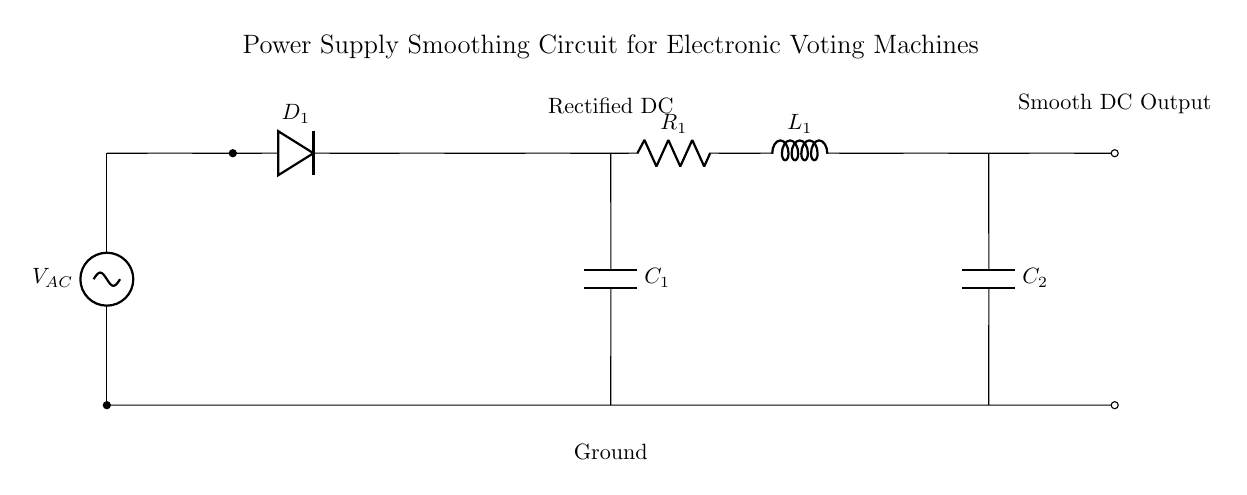What is the function of the component labeled C1? C1 acts as a filter to smooth the rectified DC voltage by storing and releasing charge, thus reducing voltage fluctuations.
Answer: Filter capacitor What components are used in the smoothing circuit? The smoothing circuit consists of a resistor, an inductor, and another capacitor, specifically R1, L1, and C2, which work together to further smooth the DC output.
Answer: R1, L1, C2 What is the primary purpose of the rectifier in this circuit? The rectifier converts the alternating current (AC) from the power supply into direct current (DC), which is essential for the operation of the electronic voting machine.
Answer: Convert AC to DC How does the inductor in this circuit contribute to smoothing? The inductor stores energy in a magnetic field when current flows through it, which helps maintain a more constant current and reduce ripples in the voltage output.
Answer: Maintain constant current What type of voltage is shown at the output terminals? The output terminals provide a smooth direct current (DC), which indicates that the rectification and smoothing components have effectively removed fluctuations.
Answer: Smooth DC What happens if the resistance of R1 is increased? Increasing the resistance of R1 would result in a longer time constant for the circuit, leading to slower charge and discharge cycles of C2, thus affecting the smoothing capability and potentially increasing voltage fluctuations.
Answer: Increased voltage fluctuations What is the significance of including a second capacitor (C2) in the circuit? The inclusion of C2 enhances the overall filtering and stabilization of the DC output by providing additional charge storage, helping to further reduce voltage ripple and increase the reliability of the power supply.
Answer: Additional charge storage 